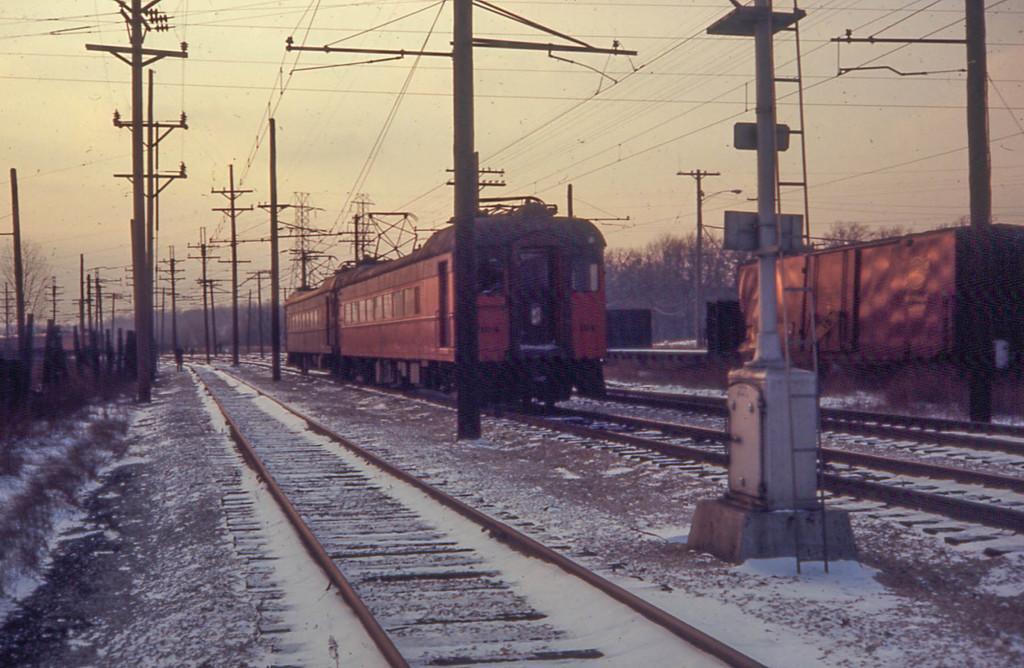How would you summarize this image in a sentence or two? There are two compartments of train on the railway track, near poles, which are having electrical lines and near other two railway tracks. In the background, there are poles which are having electrical lines, there are trees and there is sky. 